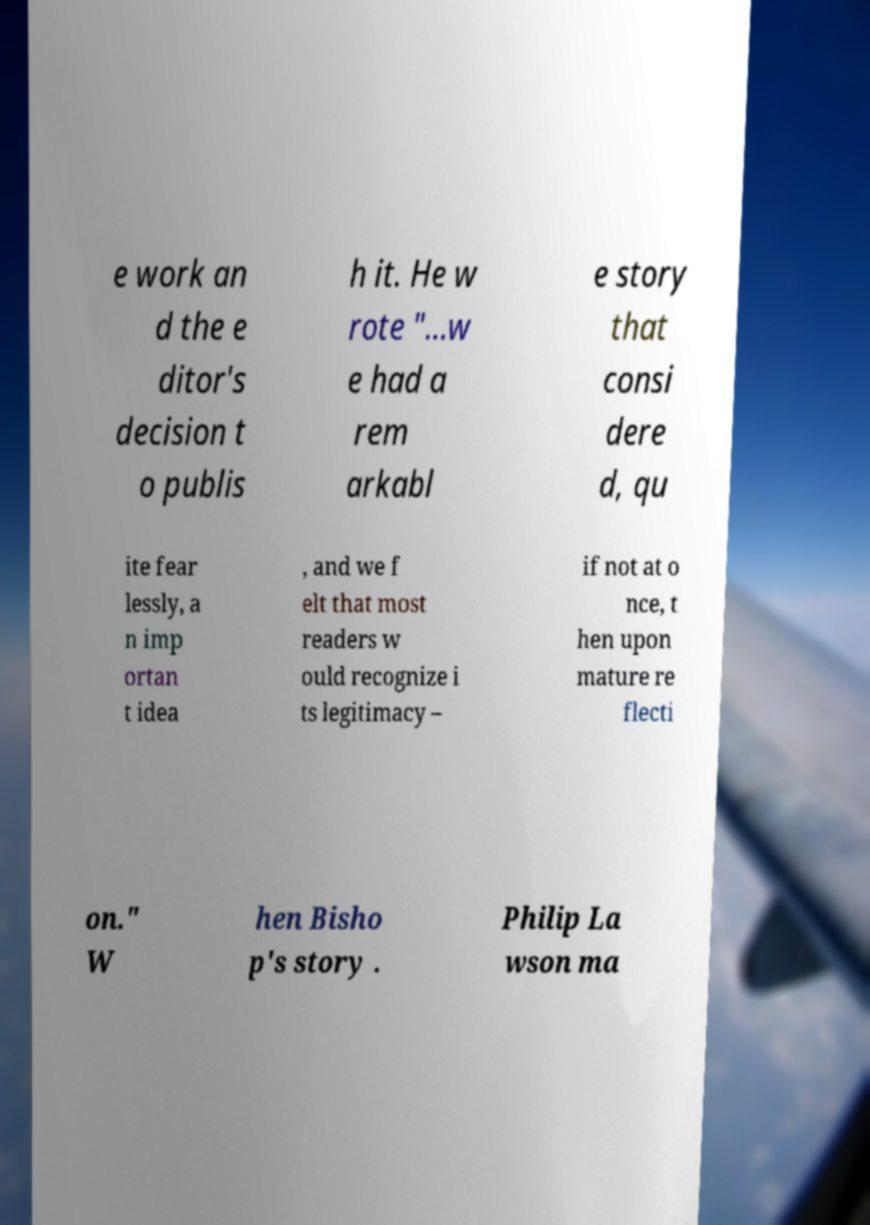I need the written content from this picture converted into text. Can you do that? e work an d the e ditor's decision t o publis h it. He w rote "…w e had a rem arkabl e story that consi dere d, qu ite fear lessly, a n imp ortan t idea , and we f elt that most readers w ould recognize i ts legitimacy – if not at o nce, t hen upon mature re flecti on." W hen Bisho p's story . Philip La wson ma 